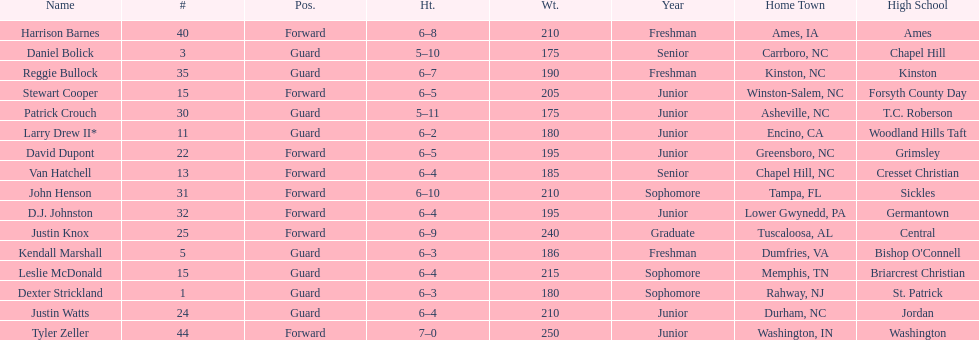Give me the full table as a dictionary. {'header': ['Name', '#', 'Pos.', 'Ht.', 'Wt.', 'Year', 'Home Town', 'High School'], 'rows': [['Harrison Barnes', '40', 'Forward', '6–8', '210', 'Freshman', 'Ames, IA', 'Ames'], ['Daniel Bolick', '3', 'Guard', '5–10', '175', 'Senior', 'Carrboro, NC', 'Chapel Hill'], ['Reggie Bullock', '35', 'Guard', '6–7', '190', 'Freshman', 'Kinston, NC', 'Kinston'], ['Stewart Cooper', '15', 'Forward', '6–5', '205', 'Junior', 'Winston-Salem, NC', 'Forsyth County Day'], ['Patrick Crouch', '30', 'Guard', '5–11', '175', 'Junior', 'Asheville, NC', 'T.C. Roberson'], ['Larry Drew II*', '11', 'Guard', '6–2', '180', 'Junior', 'Encino, CA', 'Woodland Hills Taft'], ['David Dupont', '22', 'Forward', '6–5', '195', 'Junior', 'Greensboro, NC', 'Grimsley'], ['Van Hatchell', '13', 'Forward', '6–4', '185', 'Senior', 'Chapel Hill, NC', 'Cresset Christian'], ['John Henson', '31', 'Forward', '6–10', '210', 'Sophomore', 'Tampa, FL', 'Sickles'], ['D.J. Johnston', '32', 'Forward', '6–4', '195', 'Junior', 'Lower Gwynedd, PA', 'Germantown'], ['Justin Knox', '25', 'Forward', '6–9', '240', 'Graduate', 'Tuscaloosa, AL', 'Central'], ['Kendall Marshall', '5', 'Guard', '6–3', '186', 'Freshman', 'Dumfries, VA', "Bishop O'Connell"], ['Leslie McDonald', '15', 'Guard', '6–4', '215', 'Sophomore', 'Memphis, TN', 'Briarcrest Christian'], ['Dexter Strickland', '1', 'Guard', '6–3', '180', 'Sophomore', 'Rahway, NJ', 'St. Patrick'], ['Justin Watts', '24', 'Guard', '6–4', '210', 'Junior', 'Durham, NC', 'Jordan'], ['Tyler Zeller', '44', 'Forward', '7–0', '250', 'Junior', 'Washington, IN', 'Washington']]} How many players were taller than van hatchell? 7. 